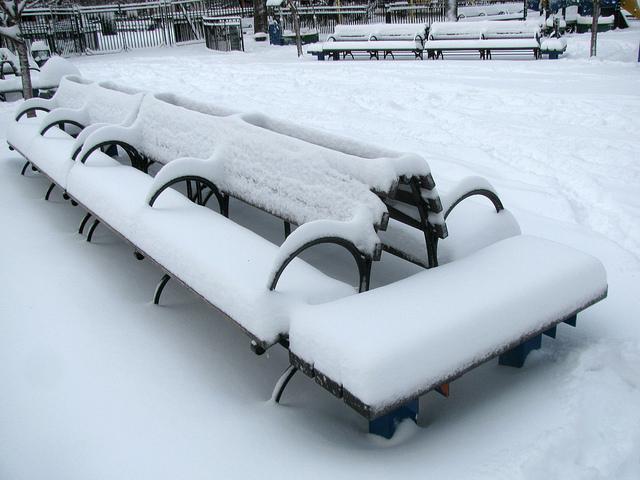How many benches are there?
Give a very brief answer. 3. 